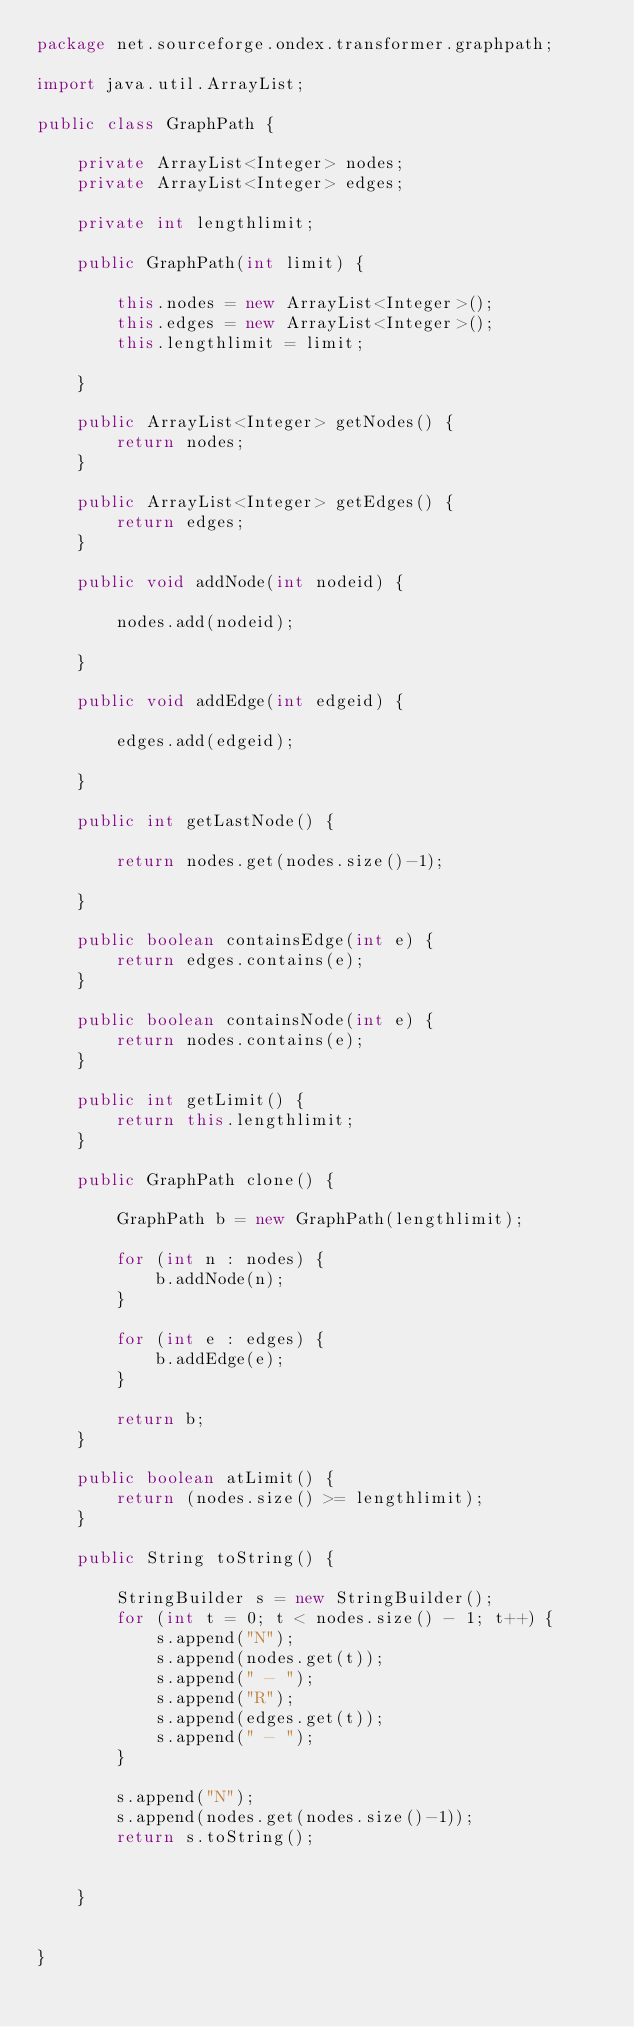Convert code to text. <code><loc_0><loc_0><loc_500><loc_500><_Java_>package net.sourceforge.ondex.transformer.graphpath;

import java.util.ArrayList;

public class GraphPath {
	
	private ArrayList<Integer> nodes;
	private ArrayList<Integer> edges;
	
	private int lengthlimit;
	
	public GraphPath(int limit) {
		
		this.nodes = new ArrayList<Integer>();
		this.edges = new ArrayList<Integer>();
		this.lengthlimit = limit;
	
	}
	
	public ArrayList<Integer> getNodes() {
		return nodes;
	}
	
	public ArrayList<Integer> getEdges() {
		return edges;
	}
	
	public void addNode(int nodeid) {
		
		nodes.add(nodeid);

	}
	
	public void addEdge(int edgeid) {
		
		edges.add(edgeid);	
		
	}
	
	public int getLastNode() {
		
		return nodes.get(nodes.size()-1);
		
	}
	
	public boolean containsEdge(int e) {
		return edges.contains(e);
	}
	
	public boolean containsNode(int e) {
		return nodes.contains(e);
	}
	
	public int getLimit() {
		return this.lengthlimit;
	}
	
	public GraphPath clone() {
	
		GraphPath b = new GraphPath(lengthlimit);
		
		for (int n : nodes) {
			b.addNode(n);
		}
		
		for (int e : edges) {
			b.addEdge(e);
		}
		
		return b;
	}
	
	public boolean atLimit() {
		return (nodes.size() >= lengthlimit);
	}
	
	public String toString() {
		
		StringBuilder s = new StringBuilder();
		for (int t = 0; t < nodes.size() - 1; t++) {
			s.append("N");
			s.append(nodes.get(t));
			s.append(" - ");
			s.append("R");
			s.append(edges.get(t));
			s.append(" - ");
		}
		
		s.append("N");
		s.append(nodes.get(nodes.size()-1));
		return s.toString();
		
		
	}
	

}
</code> 